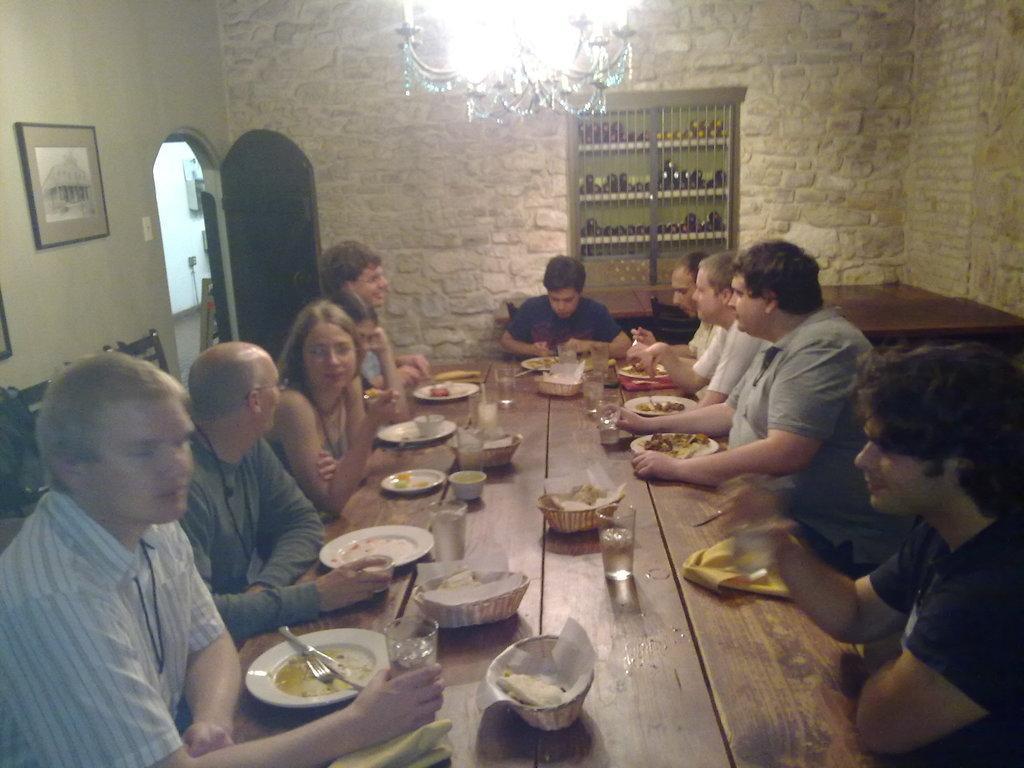Could you give a brief overview of what you see in this image? In this picture i could see some persons sitting around the table and having lunch. I could see plates spoons and forks and bowls and glasses filled with water and some food in the plate. In the back ground i could see the bottles placed in the cupboard chandelier hanging over from ceiling and wall frames on the wall and door opened. 